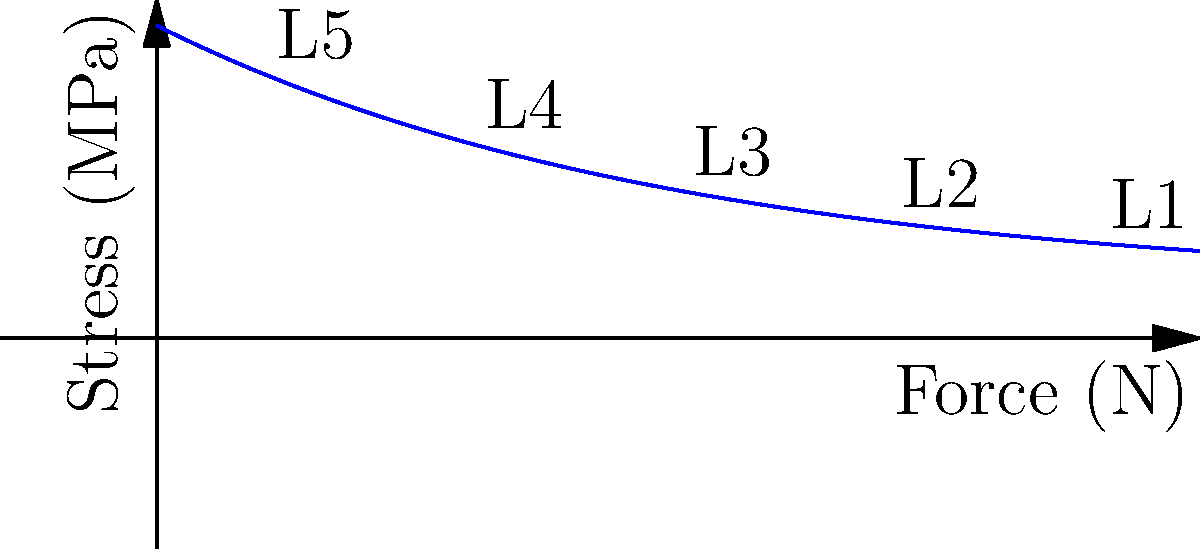In a scene from a medical drama, a patient lifts a heavy object, resulting in lower back pain. Based on the stress distribution curve shown for the lumbar vertebrae (L1-L5) during lifting, which vertebra experiences the highest stress, and how does this relate to common clinical presentations? To answer this question, let's analyze the stress distribution curve step-by-step:

1. The graph shows the stress distribution across the lumbar vertebrae (L1-L5) during lifting.
2. The y-axis represents stress in MPa (megapascals), while the x-axis represents the applied force in N (newtons).
3. The curve is exponential, with stress decreasing from L5 to L1.
4. L5 (the lowest point on the curve) experiences the highest stress, followed by L4, L3, L2, and L1.
5. This distribution is consistent with biomechanical principles:
   a. L5 is closest to the point of force application (lifting point).
   b. Each subsequent vertebra bears less load due to load distribution through intervertebral discs and surrounding tissues.
6. Clinically, this explains why L4-L5 and L5-S1 regions are most commonly affected in lower back injuries related to lifting:
   a. Higher stress increases the risk of disc herniation, facet joint issues, and muscle strain.
   b. Patients often report pain radiating from the lower back to the buttocks or legs (sciatica) due to nerve root compression at these levels.

This stress distribution pattern underscores the importance of proper lifting techniques and core strength in preventing lower back injuries, a point often emphasized in medical dramas but not always accurately portrayed.
Answer: L5 experiences the highest stress, correlating with frequent L4-L5 and L5-S1 injuries in lifting-related lower back pain cases. 